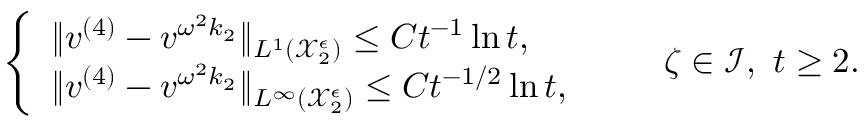Convert formula to latex. <formula><loc_0><loc_0><loc_500><loc_500>\begin{array} { r } { \left \{ \begin{array} { l l } { \| v ^ { ( 4 ) } - v ^ { \omega ^ { 2 } k _ { 2 } } \| _ { L ^ { 1 } ( \mathcal { X } _ { 2 } ^ { \epsilon } ) } \leq C t ^ { - 1 } \ln t , } \\ { \| v ^ { ( 4 ) } - v ^ { \omega ^ { 2 } k _ { 2 } } \| _ { L ^ { \infty } ( \mathcal { X } _ { 2 } ^ { \epsilon } ) } \leq C t ^ { - 1 / 2 } \ln t , } \end{array} \quad \zeta \in \mathcal { I } , \ t \geq 2 . } \end{array}</formula> 